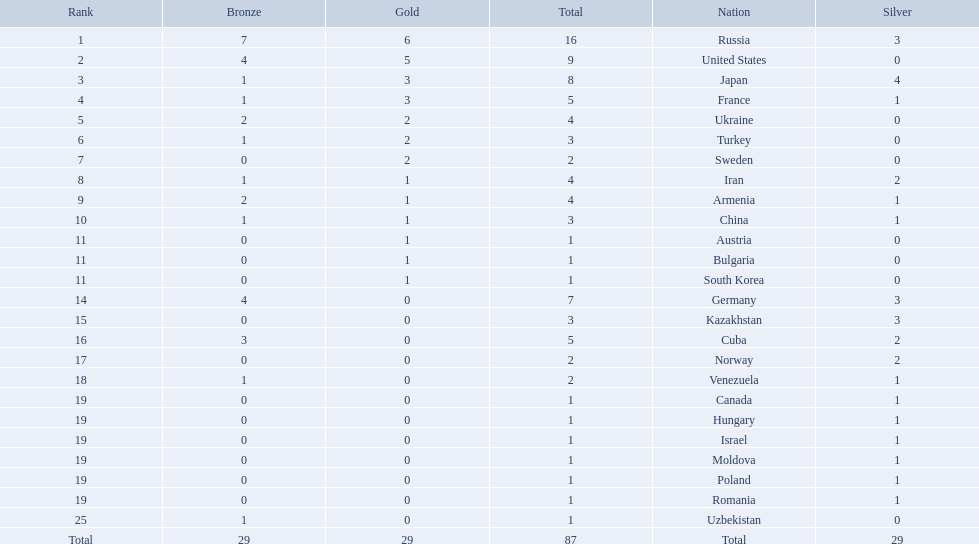What nations have one gold medal? Iran, Armenia, China, Austria, Bulgaria, South Korea. Of these, which nations have zero silver medals? Austria, Bulgaria, South Korea. Of these, which nations also have zero bronze medals? Austria. 